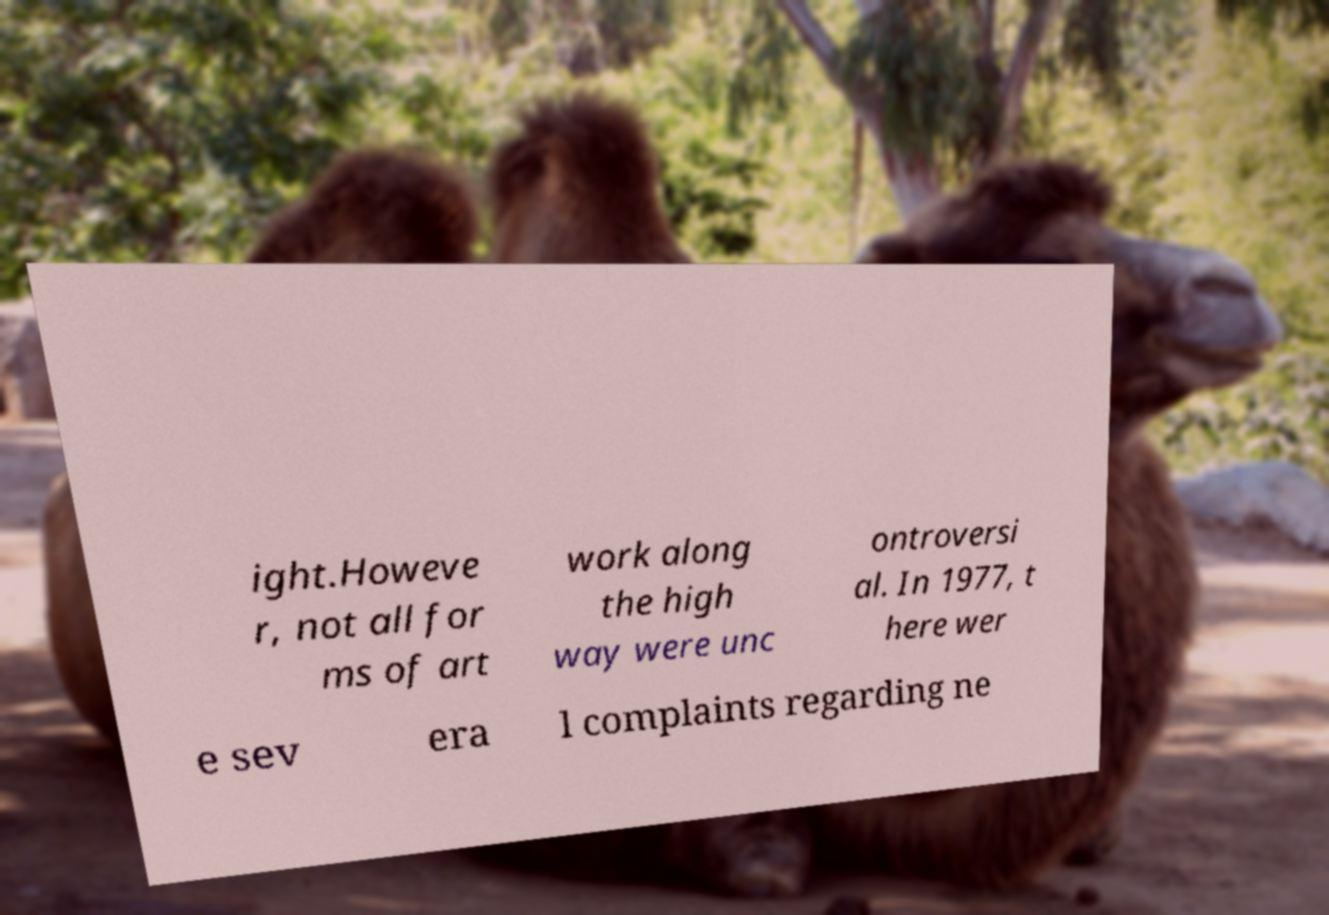Can you accurately transcribe the text from the provided image for me? ight.Howeve r, not all for ms of art work along the high way were unc ontroversi al. In 1977, t here wer e sev era l complaints regarding ne 